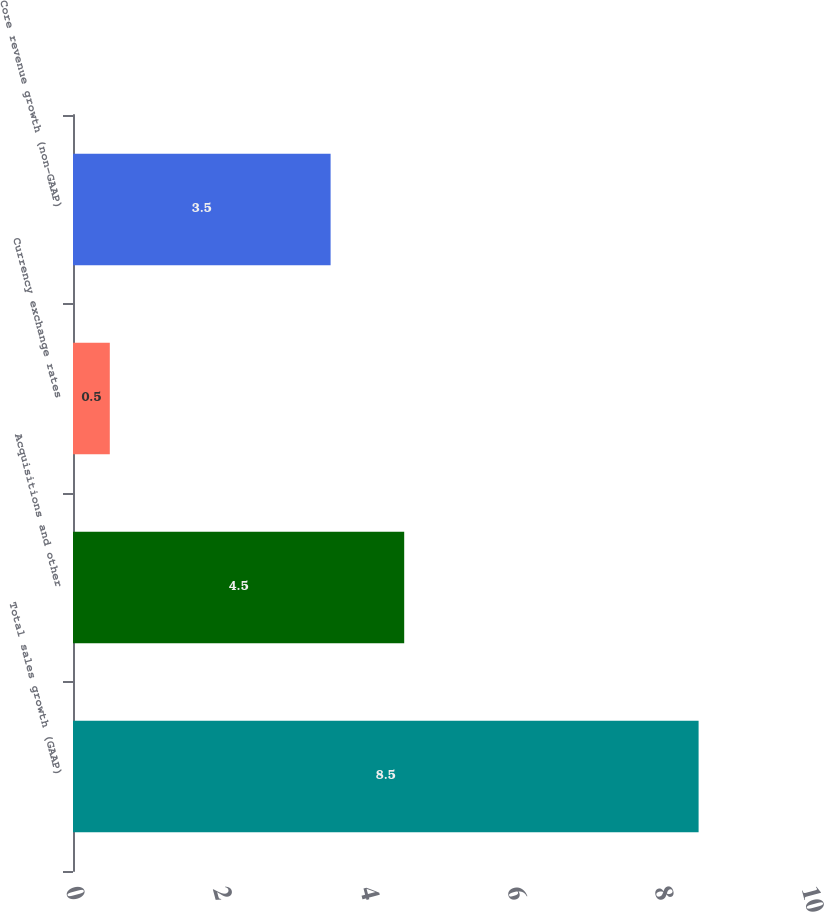Convert chart to OTSL. <chart><loc_0><loc_0><loc_500><loc_500><bar_chart><fcel>Total sales growth (GAAP)<fcel>Acquisitions and other<fcel>Currency exchange rates<fcel>Core revenue growth (non-GAAP)<nl><fcel>8.5<fcel>4.5<fcel>0.5<fcel>3.5<nl></chart> 